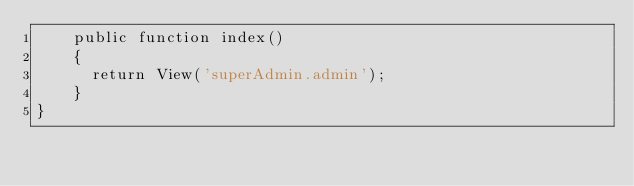Convert code to text. <code><loc_0><loc_0><loc_500><loc_500><_PHP_>    public function index()
    {
    	return View('superAdmin.admin');
    }
}
</code> 